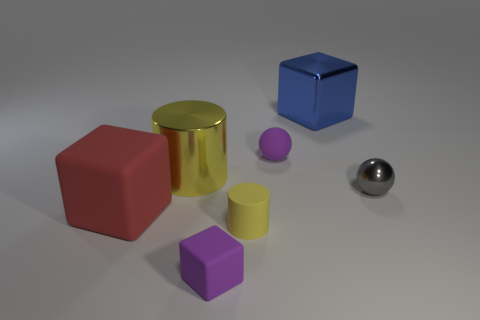There is another large object that is the same shape as the large blue shiny thing; what material is it?
Keep it short and to the point. Rubber. What number of metal cylinders are the same size as the shiny cube?
Your answer should be compact. 1. Do the gray object and the purple sphere have the same size?
Provide a succinct answer. Yes. There is a cube that is on the left side of the tiny yellow matte cylinder and right of the red block; what is its size?
Your answer should be very brief. Small. Are there more small purple things that are in front of the small yellow rubber cylinder than blue metal cubes that are behind the large blue object?
Provide a short and direct response. Yes. What is the color of the other small thing that is the same shape as the gray shiny thing?
Your answer should be very brief. Purple. There is a shiny object that is on the left side of the yellow rubber cylinder; is its color the same as the tiny matte block?
Ensure brevity in your answer.  No. What number of purple matte cubes are there?
Offer a very short reply. 1. Do the tiny object behind the large cylinder and the big yellow cylinder have the same material?
Ensure brevity in your answer.  No. Is there anything else that has the same material as the tiny purple cube?
Your answer should be compact. Yes. 